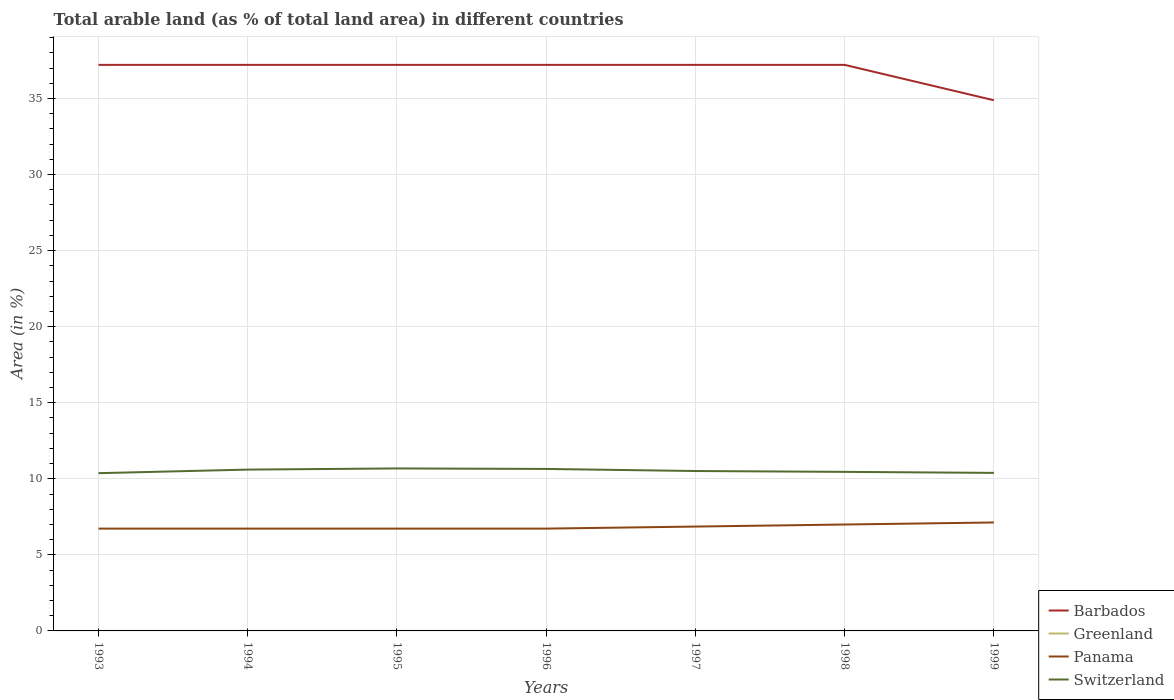Does the line corresponding to Barbados intersect with the line corresponding to Switzerland?
Make the answer very short. No. Is the number of lines equal to the number of legend labels?
Provide a succinct answer. Yes. Across all years, what is the maximum percentage of arable land in Barbados?
Give a very brief answer. 34.88. In which year was the percentage of arable land in Panama maximum?
Provide a short and direct response. 1993. What is the total percentage of arable land in Greenland in the graph?
Your answer should be compact. -0. What is the difference between the highest and the second highest percentage of arable land in Switzerland?
Ensure brevity in your answer.  0.31. What is the difference between the highest and the lowest percentage of arable land in Switzerland?
Give a very brief answer. 3. How many years are there in the graph?
Make the answer very short. 7. What is the difference between two consecutive major ticks on the Y-axis?
Offer a very short reply. 5. Does the graph contain grids?
Ensure brevity in your answer.  Yes. How are the legend labels stacked?
Offer a terse response. Vertical. What is the title of the graph?
Your answer should be very brief. Total arable land (as % of total land area) in different countries. Does "Portugal" appear as one of the legend labels in the graph?
Provide a short and direct response. No. What is the label or title of the X-axis?
Keep it short and to the point. Years. What is the label or title of the Y-axis?
Your answer should be compact. Area (in %). What is the Area (in %) of Barbados in 1993?
Provide a succinct answer. 37.21. What is the Area (in %) in Greenland in 1993?
Offer a very short reply. 0. What is the Area (in %) in Panama in 1993?
Provide a short and direct response. 6.73. What is the Area (in %) in Switzerland in 1993?
Give a very brief answer. 10.37. What is the Area (in %) in Barbados in 1994?
Make the answer very short. 37.21. What is the Area (in %) in Greenland in 1994?
Make the answer very short. 0. What is the Area (in %) of Panama in 1994?
Provide a succinct answer. 6.73. What is the Area (in %) of Switzerland in 1994?
Give a very brief answer. 10.6. What is the Area (in %) of Barbados in 1995?
Give a very brief answer. 37.21. What is the Area (in %) of Greenland in 1995?
Ensure brevity in your answer.  0. What is the Area (in %) in Panama in 1995?
Provide a short and direct response. 6.73. What is the Area (in %) of Switzerland in 1995?
Make the answer very short. 10.68. What is the Area (in %) in Barbados in 1996?
Your response must be concise. 37.21. What is the Area (in %) of Greenland in 1996?
Your answer should be compact. 0. What is the Area (in %) of Panama in 1996?
Offer a terse response. 6.73. What is the Area (in %) of Switzerland in 1996?
Provide a succinct answer. 10.65. What is the Area (in %) of Barbados in 1997?
Give a very brief answer. 37.21. What is the Area (in %) of Greenland in 1997?
Your answer should be compact. 0. What is the Area (in %) of Panama in 1997?
Make the answer very short. 6.86. What is the Area (in %) in Switzerland in 1997?
Give a very brief answer. 10.51. What is the Area (in %) in Barbados in 1998?
Provide a short and direct response. 37.21. What is the Area (in %) in Greenland in 1998?
Ensure brevity in your answer.  0. What is the Area (in %) in Panama in 1998?
Ensure brevity in your answer.  6.99. What is the Area (in %) in Switzerland in 1998?
Provide a short and direct response. 10.46. What is the Area (in %) of Barbados in 1999?
Keep it short and to the point. 34.88. What is the Area (in %) of Greenland in 1999?
Your answer should be compact. 0. What is the Area (in %) in Panama in 1999?
Offer a terse response. 7.13. What is the Area (in %) in Switzerland in 1999?
Ensure brevity in your answer.  10.39. Across all years, what is the maximum Area (in %) in Barbados?
Offer a very short reply. 37.21. Across all years, what is the maximum Area (in %) of Greenland?
Ensure brevity in your answer.  0. Across all years, what is the maximum Area (in %) in Panama?
Ensure brevity in your answer.  7.13. Across all years, what is the maximum Area (in %) of Switzerland?
Your answer should be very brief. 10.68. Across all years, what is the minimum Area (in %) in Barbados?
Your answer should be compact. 34.88. Across all years, what is the minimum Area (in %) in Greenland?
Offer a very short reply. 0. Across all years, what is the minimum Area (in %) of Panama?
Your response must be concise. 6.73. Across all years, what is the minimum Area (in %) in Switzerland?
Make the answer very short. 10.37. What is the total Area (in %) in Barbados in the graph?
Your answer should be very brief. 258.14. What is the total Area (in %) in Greenland in the graph?
Offer a very short reply. 0.01. What is the total Area (in %) of Panama in the graph?
Provide a short and direct response. 47.89. What is the total Area (in %) of Switzerland in the graph?
Your response must be concise. 73.66. What is the difference between the Area (in %) in Barbados in 1993 and that in 1994?
Offer a very short reply. 0. What is the difference between the Area (in %) in Greenland in 1993 and that in 1994?
Keep it short and to the point. 0. What is the difference between the Area (in %) in Panama in 1993 and that in 1994?
Give a very brief answer. 0. What is the difference between the Area (in %) of Switzerland in 1993 and that in 1994?
Your response must be concise. -0.24. What is the difference between the Area (in %) of Panama in 1993 and that in 1995?
Your answer should be very brief. 0. What is the difference between the Area (in %) of Switzerland in 1993 and that in 1995?
Offer a very short reply. -0.31. What is the difference between the Area (in %) of Barbados in 1993 and that in 1996?
Offer a very short reply. 0. What is the difference between the Area (in %) of Greenland in 1993 and that in 1996?
Offer a very short reply. -0. What is the difference between the Area (in %) in Switzerland in 1993 and that in 1996?
Provide a short and direct response. -0.28. What is the difference between the Area (in %) of Panama in 1993 and that in 1997?
Provide a short and direct response. -0.13. What is the difference between the Area (in %) of Switzerland in 1993 and that in 1997?
Ensure brevity in your answer.  -0.14. What is the difference between the Area (in %) of Panama in 1993 and that in 1998?
Ensure brevity in your answer.  -0.27. What is the difference between the Area (in %) of Switzerland in 1993 and that in 1998?
Provide a short and direct response. -0.09. What is the difference between the Area (in %) of Barbados in 1993 and that in 1999?
Your response must be concise. 2.33. What is the difference between the Area (in %) of Greenland in 1993 and that in 1999?
Provide a succinct answer. 0. What is the difference between the Area (in %) of Panama in 1993 and that in 1999?
Your answer should be compact. -0.4. What is the difference between the Area (in %) in Switzerland in 1993 and that in 1999?
Provide a succinct answer. -0.02. What is the difference between the Area (in %) of Panama in 1994 and that in 1995?
Offer a terse response. 0. What is the difference between the Area (in %) of Switzerland in 1994 and that in 1995?
Make the answer very short. -0.08. What is the difference between the Area (in %) of Barbados in 1994 and that in 1996?
Ensure brevity in your answer.  0. What is the difference between the Area (in %) of Greenland in 1994 and that in 1996?
Your response must be concise. -0. What is the difference between the Area (in %) in Switzerland in 1994 and that in 1996?
Offer a very short reply. -0.04. What is the difference between the Area (in %) of Panama in 1994 and that in 1997?
Your answer should be compact. -0.13. What is the difference between the Area (in %) in Switzerland in 1994 and that in 1997?
Make the answer very short. 0.09. What is the difference between the Area (in %) of Panama in 1994 and that in 1998?
Your response must be concise. -0.27. What is the difference between the Area (in %) in Switzerland in 1994 and that in 1998?
Ensure brevity in your answer.  0.15. What is the difference between the Area (in %) of Barbados in 1994 and that in 1999?
Offer a terse response. 2.33. What is the difference between the Area (in %) of Greenland in 1994 and that in 1999?
Your answer should be compact. 0. What is the difference between the Area (in %) in Panama in 1994 and that in 1999?
Keep it short and to the point. -0.4. What is the difference between the Area (in %) of Switzerland in 1994 and that in 1999?
Your answer should be compact. 0.22. What is the difference between the Area (in %) of Greenland in 1995 and that in 1996?
Provide a short and direct response. -0. What is the difference between the Area (in %) in Panama in 1995 and that in 1996?
Offer a very short reply. 0. What is the difference between the Area (in %) of Switzerland in 1995 and that in 1996?
Provide a short and direct response. 0.03. What is the difference between the Area (in %) of Greenland in 1995 and that in 1997?
Give a very brief answer. 0. What is the difference between the Area (in %) of Panama in 1995 and that in 1997?
Give a very brief answer. -0.13. What is the difference between the Area (in %) in Switzerland in 1995 and that in 1997?
Provide a succinct answer. 0.17. What is the difference between the Area (in %) of Barbados in 1995 and that in 1998?
Offer a very short reply. 0. What is the difference between the Area (in %) in Panama in 1995 and that in 1998?
Your answer should be compact. -0.27. What is the difference between the Area (in %) of Switzerland in 1995 and that in 1998?
Your response must be concise. 0.22. What is the difference between the Area (in %) of Barbados in 1995 and that in 1999?
Offer a very short reply. 2.33. What is the difference between the Area (in %) of Greenland in 1995 and that in 1999?
Give a very brief answer. 0. What is the difference between the Area (in %) in Panama in 1995 and that in 1999?
Your answer should be very brief. -0.4. What is the difference between the Area (in %) in Switzerland in 1995 and that in 1999?
Provide a succinct answer. 0.29. What is the difference between the Area (in %) of Panama in 1996 and that in 1997?
Make the answer very short. -0.13. What is the difference between the Area (in %) in Switzerland in 1996 and that in 1997?
Your answer should be very brief. 0.14. What is the difference between the Area (in %) of Barbados in 1996 and that in 1998?
Your answer should be very brief. 0. What is the difference between the Area (in %) in Greenland in 1996 and that in 1998?
Ensure brevity in your answer.  0. What is the difference between the Area (in %) of Panama in 1996 and that in 1998?
Your response must be concise. -0.27. What is the difference between the Area (in %) in Switzerland in 1996 and that in 1998?
Your response must be concise. 0.19. What is the difference between the Area (in %) in Barbados in 1996 and that in 1999?
Offer a very short reply. 2.33. What is the difference between the Area (in %) in Panama in 1996 and that in 1999?
Your answer should be compact. -0.4. What is the difference between the Area (in %) of Switzerland in 1996 and that in 1999?
Ensure brevity in your answer.  0.26. What is the difference between the Area (in %) of Barbados in 1997 and that in 1998?
Keep it short and to the point. 0. What is the difference between the Area (in %) in Panama in 1997 and that in 1998?
Ensure brevity in your answer.  -0.13. What is the difference between the Area (in %) in Switzerland in 1997 and that in 1998?
Offer a very short reply. 0.06. What is the difference between the Area (in %) in Barbados in 1997 and that in 1999?
Keep it short and to the point. 2.33. What is the difference between the Area (in %) in Greenland in 1997 and that in 1999?
Offer a very short reply. 0. What is the difference between the Area (in %) in Panama in 1997 and that in 1999?
Make the answer very short. -0.27. What is the difference between the Area (in %) in Switzerland in 1997 and that in 1999?
Give a very brief answer. 0.12. What is the difference between the Area (in %) in Barbados in 1998 and that in 1999?
Ensure brevity in your answer.  2.33. What is the difference between the Area (in %) in Panama in 1998 and that in 1999?
Your answer should be compact. -0.13. What is the difference between the Area (in %) in Switzerland in 1998 and that in 1999?
Provide a short and direct response. 0.07. What is the difference between the Area (in %) in Barbados in 1993 and the Area (in %) in Greenland in 1994?
Provide a short and direct response. 37.21. What is the difference between the Area (in %) in Barbados in 1993 and the Area (in %) in Panama in 1994?
Ensure brevity in your answer.  30.48. What is the difference between the Area (in %) of Barbados in 1993 and the Area (in %) of Switzerland in 1994?
Ensure brevity in your answer.  26.6. What is the difference between the Area (in %) in Greenland in 1993 and the Area (in %) in Panama in 1994?
Offer a very short reply. -6.72. What is the difference between the Area (in %) in Greenland in 1993 and the Area (in %) in Switzerland in 1994?
Offer a very short reply. -10.6. What is the difference between the Area (in %) in Panama in 1993 and the Area (in %) in Switzerland in 1994?
Your answer should be compact. -3.88. What is the difference between the Area (in %) of Barbados in 1993 and the Area (in %) of Greenland in 1995?
Your answer should be compact. 37.21. What is the difference between the Area (in %) in Barbados in 1993 and the Area (in %) in Panama in 1995?
Your answer should be very brief. 30.48. What is the difference between the Area (in %) in Barbados in 1993 and the Area (in %) in Switzerland in 1995?
Give a very brief answer. 26.53. What is the difference between the Area (in %) of Greenland in 1993 and the Area (in %) of Panama in 1995?
Provide a succinct answer. -6.72. What is the difference between the Area (in %) of Greenland in 1993 and the Area (in %) of Switzerland in 1995?
Provide a succinct answer. -10.68. What is the difference between the Area (in %) in Panama in 1993 and the Area (in %) in Switzerland in 1995?
Your response must be concise. -3.95. What is the difference between the Area (in %) in Barbados in 1993 and the Area (in %) in Greenland in 1996?
Ensure brevity in your answer.  37.21. What is the difference between the Area (in %) of Barbados in 1993 and the Area (in %) of Panama in 1996?
Make the answer very short. 30.48. What is the difference between the Area (in %) of Barbados in 1993 and the Area (in %) of Switzerland in 1996?
Keep it short and to the point. 26.56. What is the difference between the Area (in %) of Greenland in 1993 and the Area (in %) of Panama in 1996?
Provide a succinct answer. -6.72. What is the difference between the Area (in %) in Greenland in 1993 and the Area (in %) in Switzerland in 1996?
Offer a very short reply. -10.65. What is the difference between the Area (in %) of Panama in 1993 and the Area (in %) of Switzerland in 1996?
Offer a terse response. -3.92. What is the difference between the Area (in %) in Barbados in 1993 and the Area (in %) in Greenland in 1997?
Provide a succinct answer. 37.21. What is the difference between the Area (in %) in Barbados in 1993 and the Area (in %) in Panama in 1997?
Ensure brevity in your answer.  30.35. What is the difference between the Area (in %) in Barbados in 1993 and the Area (in %) in Switzerland in 1997?
Your response must be concise. 26.7. What is the difference between the Area (in %) of Greenland in 1993 and the Area (in %) of Panama in 1997?
Provide a short and direct response. -6.86. What is the difference between the Area (in %) of Greenland in 1993 and the Area (in %) of Switzerland in 1997?
Give a very brief answer. -10.51. What is the difference between the Area (in %) in Panama in 1993 and the Area (in %) in Switzerland in 1997?
Ensure brevity in your answer.  -3.79. What is the difference between the Area (in %) in Barbados in 1993 and the Area (in %) in Greenland in 1998?
Offer a terse response. 37.21. What is the difference between the Area (in %) in Barbados in 1993 and the Area (in %) in Panama in 1998?
Ensure brevity in your answer.  30.21. What is the difference between the Area (in %) of Barbados in 1993 and the Area (in %) of Switzerland in 1998?
Your response must be concise. 26.75. What is the difference between the Area (in %) in Greenland in 1993 and the Area (in %) in Panama in 1998?
Offer a very short reply. -6.99. What is the difference between the Area (in %) in Greenland in 1993 and the Area (in %) in Switzerland in 1998?
Provide a succinct answer. -10.45. What is the difference between the Area (in %) of Panama in 1993 and the Area (in %) of Switzerland in 1998?
Your response must be concise. -3.73. What is the difference between the Area (in %) of Barbados in 1993 and the Area (in %) of Greenland in 1999?
Make the answer very short. 37.21. What is the difference between the Area (in %) of Barbados in 1993 and the Area (in %) of Panama in 1999?
Offer a terse response. 30.08. What is the difference between the Area (in %) in Barbados in 1993 and the Area (in %) in Switzerland in 1999?
Your response must be concise. 26.82. What is the difference between the Area (in %) of Greenland in 1993 and the Area (in %) of Panama in 1999?
Offer a very short reply. -7.13. What is the difference between the Area (in %) of Greenland in 1993 and the Area (in %) of Switzerland in 1999?
Make the answer very short. -10.39. What is the difference between the Area (in %) of Panama in 1993 and the Area (in %) of Switzerland in 1999?
Your answer should be very brief. -3.66. What is the difference between the Area (in %) in Barbados in 1994 and the Area (in %) in Greenland in 1995?
Your answer should be compact. 37.21. What is the difference between the Area (in %) in Barbados in 1994 and the Area (in %) in Panama in 1995?
Ensure brevity in your answer.  30.48. What is the difference between the Area (in %) in Barbados in 1994 and the Area (in %) in Switzerland in 1995?
Provide a succinct answer. 26.53. What is the difference between the Area (in %) in Greenland in 1994 and the Area (in %) in Panama in 1995?
Your response must be concise. -6.72. What is the difference between the Area (in %) of Greenland in 1994 and the Area (in %) of Switzerland in 1995?
Your response must be concise. -10.68. What is the difference between the Area (in %) of Panama in 1994 and the Area (in %) of Switzerland in 1995?
Make the answer very short. -3.95. What is the difference between the Area (in %) in Barbados in 1994 and the Area (in %) in Greenland in 1996?
Offer a very short reply. 37.21. What is the difference between the Area (in %) of Barbados in 1994 and the Area (in %) of Panama in 1996?
Your response must be concise. 30.48. What is the difference between the Area (in %) of Barbados in 1994 and the Area (in %) of Switzerland in 1996?
Ensure brevity in your answer.  26.56. What is the difference between the Area (in %) in Greenland in 1994 and the Area (in %) in Panama in 1996?
Give a very brief answer. -6.72. What is the difference between the Area (in %) in Greenland in 1994 and the Area (in %) in Switzerland in 1996?
Ensure brevity in your answer.  -10.65. What is the difference between the Area (in %) in Panama in 1994 and the Area (in %) in Switzerland in 1996?
Ensure brevity in your answer.  -3.92. What is the difference between the Area (in %) of Barbados in 1994 and the Area (in %) of Greenland in 1997?
Offer a very short reply. 37.21. What is the difference between the Area (in %) in Barbados in 1994 and the Area (in %) in Panama in 1997?
Ensure brevity in your answer.  30.35. What is the difference between the Area (in %) in Barbados in 1994 and the Area (in %) in Switzerland in 1997?
Give a very brief answer. 26.7. What is the difference between the Area (in %) of Greenland in 1994 and the Area (in %) of Panama in 1997?
Your response must be concise. -6.86. What is the difference between the Area (in %) of Greenland in 1994 and the Area (in %) of Switzerland in 1997?
Keep it short and to the point. -10.51. What is the difference between the Area (in %) in Panama in 1994 and the Area (in %) in Switzerland in 1997?
Give a very brief answer. -3.79. What is the difference between the Area (in %) in Barbados in 1994 and the Area (in %) in Greenland in 1998?
Provide a succinct answer. 37.21. What is the difference between the Area (in %) in Barbados in 1994 and the Area (in %) in Panama in 1998?
Offer a very short reply. 30.21. What is the difference between the Area (in %) in Barbados in 1994 and the Area (in %) in Switzerland in 1998?
Give a very brief answer. 26.75. What is the difference between the Area (in %) in Greenland in 1994 and the Area (in %) in Panama in 1998?
Offer a terse response. -6.99. What is the difference between the Area (in %) in Greenland in 1994 and the Area (in %) in Switzerland in 1998?
Provide a succinct answer. -10.45. What is the difference between the Area (in %) of Panama in 1994 and the Area (in %) of Switzerland in 1998?
Keep it short and to the point. -3.73. What is the difference between the Area (in %) in Barbados in 1994 and the Area (in %) in Greenland in 1999?
Your answer should be very brief. 37.21. What is the difference between the Area (in %) in Barbados in 1994 and the Area (in %) in Panama in 1999?
Give a very brief answer. 30.08. What is the difference between the Area (in %) of Barbados in 1994 and the Area (in %) of Switzerland in 1999?
Make the answer very short. 26.82. What is the difference between the Area (in %) of Greenland in 1994 and the Area (in %) of Panama in 1999?
Your answer should be compact. -7.13. What is the difference between the Area (in %) of Greenland in 1994 and the Area (in %) of Switzerland in 1999?
Make the answer very short. -10.39. What is the difference between the Area (in %) of Panama in 1994 and the Area (in %) of Switzerland in 1999?
Your answer should be compact. -3.66. What is the difference between the Area (in %) in Barbados in 1995 and the Area (in %) in Greenland in 1996?
Offer a very short reply. 37.21. What is the difference between the Area (in %) in Barbados in 1995 and the Area (in %) in Panama in 1996?
Give a very brief answer. 30.48. What is the difference between the Area (in %) in Barbados in 1995 and the Area (in %) in Switzerland in 1996?
Make the answer very short. 26.56. What is the difference between the Area (in %) of Greenland in 1995 and the Area (in %) of Panama in 1996?
Keep it short and to the point. -6.72. What is the difference between the Area (in %) of Greenland in 1995 and the Area (in %) of Switzerland in 1996?
Offer a very short reply. -10.65. What is the difference between the Area (in %) of Panama in 1995 and the Area (in %) of Switzerland in 1996?
Give a very brief answer. -3.92. What is the difference between the Area (in %) in Barbados in 1995 and the Area (in %) in Greenland in 1997?
Your answer should be very brief. 37.21. What is the difference between the Area (in %) of Barbados in 1995 and the Area (in %) of Panama in 1997?
Your answer should be very brief. 30.35. What is the difference between the Area (in %) in Barbados in 1995 and the Area (in %) in Switzerland in 1997?
Give a very brief answer. 26.7. What is the difference between the Area (in %) in Greenland in 1995 and the Area (in %) in Panama in 1997?
Provide a succinct answer. -6.86. What is the difference between the Area (in %) in Greenland in 1995 and the Area (in %) in Switzerland in 1997?
Your answer should be very brief. -10.51. What is the difference between the Area (in %) of Panama in 1995 and the Area (in %) of Switzerland in 1997?
Give a very brief answer. -3.79. What is the difference between the Area (in %) of Barbados in 1995 and the Area (in %) of Greenland in 1998?
Your response must be concise. 37.21. What is the difference between the Area (in %) in Barbados in 1995 and the Area (in %) in Panama in 1998?
Offer a very short reply. 30.21. What is the difference between the Area (in %) in Barbados in 1995 and the Area (in %) in Switzerland in 1998?
Offer a very short reply. 26.75. What is the difference between the Area (in %) of Greenland in 1995 and the Area (in %) of Panama in 1998?
Make the answer very short. -6.99. What is the difference between the Area (in %) of Greenland in 1995 and the Area (in %) of Switzerland in 1998?
Offer a very short reply. -10.45. What is the difference between the Area (in %) of Panama in 1995 and the Area (in %) of Switzerland in 1998?
Give a very brief answer. -3.73. What is the difference between the Area (in %) in Barbados in 1995 and the Area (in %) in Greenland in 1999?
Your answer should be compact. 37.21. What is the difference between the Area (in %) in Barbados in 1995 and the Area (in %) in Panama in 1999?
Offer a very short reply. 30.08. What is the difference between the Area (in %) in Barbados in 1995 and the Area (in %) in Switzerland in 1999?
Offer a terse response. 26.82. What is the difference between the Area (in %) of Greenland in 1995 and the Area (in %) of Panama in 1999?
Make the answer very short. -7.13. What is the difference between the Area (in %) of Greenland in 1995 and the Area (in %) of Switzerland in 1999?
Offer a very short reply. -10.39. What is the difference between the Area (in %) of Panama in 1995 and the Area (in %) of Switzerland in 1999?
Provide a short and direct response. -3.66. What is the difference between the Area (in %) of Barbados in 1996 and the Area (in %) of Greenland in 1997?
Offer a terse response. 37.21. What is the difference between the Area (in %) in Barbados in 1996 and the Area (in %) in Panama in 1997?
Offer a terse response. 30.35. What is the difference between the Area (in %) of Barbados in 1996 and the Area (in %) of Switzerland in 1997?
Make the answer very short. 26.7. What is the difference between the Area (in %) of Greenland in 1996 and the Area (in %) of Panama in 1997?
Your response must be concise. -6.86. What is the difference between the Area (in %) in Greenland in 1996 and the Area (in %) in Switzerland in 1997?
Provide a short and direct response. -10.51. What is the difference between the Area (in %) in Panama in 1996 and the Area (in %) in Switzerland in 1997?
Provide a short and direct response. -3.79. What is the difference between the Area (in %) of Barbados in 1996 and the Area (in %) of Greenland in 1998?
Provide a succinct answer. 37.21. What is the difference between the Area (in %) of Barbados in 1996 and the Area (in %) of Panama in 1998?
Your answer should be very brief. 30.21. What is the difference between the Area (in %) of Barbados in 1996 and the Area (in %) of Switzerland in 1998?
Keep it short and to the point. 26.75. What is the difference between the Area (in %) in Greenland in 1996 and the Area (in %) in Panama in 1998?
Offer a very short reply. -6.99. What is the difference between the Area (in %) in Greenland in 1996 and the Area (in %) in Switzerland in 1998?
Provide a short and direct response. -10.45. What is the difference between the Area (in %) in Panama in 1996 and the Area (in %) in Switzerland in 1998?
Keep it short and to the point. -3.73. What is the difference between the Area (in %) in Barbados in 1996 and the Area (in %) in Greenland in 1999?
Make the answer very short. 37.21. What is the difference between the Area (in %) in Barbados in 1996 and the Area (in %) in Panama in 1999?
Ensure brevity in your answer.  30.08. What is the difference between the Area (in %) of Barbados in 1996 and the Area (in %) of Switzerland in 1999?
Offer a terse response. 26.82. What is the difference between the Area (in %) of Greenland in 1996 and the Area (in %) of Panama in 1999?
Provide a short and direct response. -7.13. What is the difference between the Area (in %) in Greenland in 1996 and the Area (in %) in Switzerland in 1999?
Make the answer very short. -10.39. What is the difference between the Area (in %) in Panama in 1996 and the Area (in %) in Switzerland in 1999?
Ensure brevity in your answer.  -3.66. What is the difference between the Area (in %) of Barbados in 1997 and the Area (in %) of Greenland in 1998?
Keep it short and to the point. 37.21. What is the difference between the Area (in %) of Barbados in 1997 and the Area (in %) of Panama in 1998?
Give a very brief answer. 30.21. What is the difference between the Area (in %) of Barbados in 1997 and the Area (in %) of Switzerland in 1998?
Your answer should be compact. 26.75. What is the difference between the Area (in %) of Greenland in 1997 and the Area (in %) of Panama in 1998?
Give a very brief answer. -6.99. What is the difference between the Area (in %) in Greenland in 1997 and the Area (in %) in Switzerland in 1998?
Give a very brief answer. -10.45. What is the difference between the Area (in %) in Panama in 1997 and the Area (in %) in Switzerland in 1998?
Your answer should be very brief. -3.6. What is the difference between the Area (in %) of Barbados in 1997 and the Area (in %) of Greenland in 1999?
Give a very brief answer. 37.21. What is the difference between the Area (in %) of Barbados in 1997 and the Area (in %) of Panama in 1999?
Make the answer very short. 30.08. What is the difference between the Area (in %) of Barbados in 1997 and the Area (in %) of Switzerland in 1999?
Offer a very short reply. 26.82. What is the difference between the Area (in %) in Greenland in 1997 and the Area (in %) in Panama in 1999?
Offer a very short reply. -7.13. What is the difference between the Area (in %) of Greenland in 1997 and the Area (in %) of Switzerland in 1999?
Offer a terse response. -10.39. What is the difference between the Area (in %) of Panama in 1997 and the Area (in %) of Switzerland in 1999?
Keep it short and to the point. -3.53. What is the difference between the Area (in %) in Barbados in 1998 and the Area (in %) in Greenland in 1999?
Ensure brevity in your answer.  37.21. What is the difference between the Area (in %) of Barbados in 1998 and the Area (in %) of Panama in 1999?
Provide a succinct answer. 30.08. What is the difference between the Area (in %) in Barbados in 1998 and the Area (in %) in Switzerland in 1999?
Offer a terse response. 26.82. What is the difference between the Area (in %) of Greenland in 1998 and the Area (in %) of Panama in 1999?
Your answer should be compact. -7.13. What is the difference between the Area (in %) of Greenland in 1998 and the Area (in %) of Switzerland in 1999?
Make the answer very short. -10.39. What is the difference between the Area (in %) of Panama in 1998 and the Area (in %) of Switzerland in 1999?
Provide a succinct answer. -3.39. What is the average Area (in %) in Barbados per year?
Offer a very short reply. 36.88. What is the average Area (in %) of Greenland per year?
Make the answer very short. 0. What is the average Area (in %) of Panama per year?
Your answer should be very brief. 6.84. What is the average Area (in %) of Switzerland per year?
Give a very brief answer. 10.52. In the year 1993, what is the difference between the Area (in %) of Barbados and Area (in %) of Greenland?
Give a very brief answer. 37.21. In the year 1993, what is the difference between the Area (in %) of Barbados and Area (in %) of Panama?
Provide a short and direct response. 30.48. In the year 1993, what is the difference between the Area (in %) in Barbados and Area (in %) in Switzerland?
Your answer should be very brief. 26.84. In the year 1993, what is the difference between the Area (in %) of Greenland and Area (in %) of Panama?
Offer a very short reply. -6.72. In the year 1993, what is the difference between the Area (in %) of Greenland and Area (in %) of Switzerland?
Give a very brief answer. -10.37. In the year 1993, what is the difference between the Area (in %) in Panama and Area (in %) in Switzerland?
Your response must be concise. -3.64. In the year 1994, what is the difference between the Area (in %) of Barbados and Area (in %) of Greenland?
Ensure brevity in your answer.  37.21. In the year 1994, what is the difference between the Area (in %) of Barbados and Area (in %) of Panama?
Provide a short and direct response. 30.48. In the year 1994, what is the difference between the Area (in %) in Barbados and Area (in %) in Switzerland?
Keep it short and to the point. 26.6. In the year 1994, what is the difference between the Area (in %) in Greenland and Area (in %) in Panama?
Give a very brief answer. -6.72. In the year 1994, what is the difference between the Area (in %) in Greenland and Area (in %) in Switzerland?
Ensure brevity in your answer.  -10.6. In the year 1994, what is the difference between the Area (in %) in Panama and Area (in %) in Switzerland?
Offer a terse response. -3.88. In the year 1995, what is the difference between the Area (in %) in Barbados and Area (in %) in Greenland?
Give a very brief answer. 37.21. In the year 1995, what is the difference between the Area (in %) of Barbados and Area (in %) of Panama?
Give a very brief answer. 30.48. In the year 1995, what is the difference between the Area (in %) of Barbados and Area (in %) of Switzerland?
Give a very brief answer. 26.53. In the year 1995, what is the difference between the Area (in %) of Greenland and Area (in %) of Panama?
Make the answer very short. -6.72. In the year 1995, what is the difference between the Area (in %) in Greenland and Area (in %) in Switzerland?
Provide a succinct answer. -10.68. In the year 1995, what is the difference between the Area (in %) of Panama and Area (in %) of Switzerland?
Give a very brief answer. -3.95. In the year 1996, what is the difference between the Area (in %) in Barbados and Area (in %) in Greenland?
Ensure brevity in your answer.  37.21. In the year 1996, what is the difference between the Area (in %) in Barbados and Area (in %) in Panama?
Provide a short and direct response. 30.48. In the year 1996, what is the difference between the Area (in %) in Barbados and Area (in %) in Switzerland?
Make the answer very short. 26.56. In the year 1996, what is the difference between the Area (in %) of Greenland and Area (in %) of Panama?
Your answer should be compact. -6.72. In the year 1996, what is the difference between the Area (in %) in Greenland and Area (in %) in Switzerland?
Give a very brief answer. -10.65. In the year 1996, what is the difference between the Area (in %) in Panama and Area (in %) in Switzerland?
Your response must be concise. -3.92. In the year 1997, what is the difference between the Area (in %) of Barbados and Area (in %) of Greenland?
Provide a succinct answer. 37.21. In the year 1997, what is the difference between the Area (in %) in Barbados and Area (in %) in Panama?
Provide a short and direct response. 30.35. In the year 1997, what is the difference between the Area (in %) of Barbados and Area (in %) of Switzerland?
Your answer should be very brief. 26.7. In the year 1997, what is the difference between the Area (in %) in Greenland and Area (in %) in Panama?
Your answer should be very brief. -6.86. In the year 1997, what is the difference between the Area (in %) in Greenland and Area (in %) in Switzerland?
Keep it short and to the point. -10.51. In the year 1997, what is the difference between the Area (in %) of Panama and Area (in %) of Switzerland?
Your answer should be very brief. -3.65. In the year 1998, what is the difference between the Area (in %) of Barbados and Area (in %) of Greenland?
Your answer should be very brief. 37.21. In the year 1998, what is the difference between the Area (in %) of Barbados and Area (in %) of Panama?
Offer a terse response. 30.21. In the year 1998, what is the difference between the Area (in %) in Barbados and Area (in %) in Switzerland?
Keep it short and to the point. 26.75. In the year 1998, what is the difference between the Area (in %) of Greenland and Area (in %) of Panama?
Provide a short and direct response. -6.99. In the year 1998, what is the difference between the Area (in %) of Greenland and Area (in %) of Switzerland?
Keep it short and to the point. -10.45. In the year 1998, what is the difference between the Area (in %) in Panama and Area (in %) in Switzerland?
Your answer should be compact. -3.46. In the year 1999, what is the difference between the Area (in %) of Barbados and Area (in %) of Greenland?
Provide a succinct answer. 34.88. In the year 1999, what is the difference between the Area (in %) in Barbados and Area (in %) in Panama?
Ensure brevity in your answer.  27.75. In the year 1999, what is the difference between the Area (in %) in Barbados and Area (in %) in Switzerland?
Keep it short and to the point. 24.5. In the year 1999, what is the difference between the Area (in %) of Greenland and Area (in %) of Panama?
Make the answer very short. -7.13. In the year 1999, what is the difference between the Area (in %) of Greenland and Area (in %) of Switzerland?
Your response must be concise. -10.39. In the year 1999, what is the difference between the Area (in %) in Panama and Area (in %) in Switzerland?
Offer a terse response. -3.26. What is the ratio of the Area (in %) of Barbados in 1993 to that in 1994?
Provide a succinct answer. 1. What is the ratio of the Area (in %) in Switzerland in 1993 to that in 1994?
Give a very brief answer. 0.98. What is the ratio of the Area (in %) in Barbados in 1993 to that in 1995?
Offer a very short reply. 1. What is the ratio of the Area (in %) of Greenland in 1993 to that in 1995?
Ensure brevity in your answer.  1. What is the ratio of the Area (in %) of Panama in 1993 to that in 1995?
Your answer should be very brief. 1. What is the ratio of the Area (in %) of Switzerland in 1993 to that in 1995?
Ensure brevity in your answer.  0.97. What is the ratio of the Area (in %) of Greenland in 1993 to that in 1996?
Make the answer very short. 0.86. What is the ratio of the Area (in %) of Panama in 1993 to that in 1996?
Ensure brevity in your answer.  1. What is the ratio of the Area (in %) in Switzerland in 1993 to that in 1996?
Your response must be concise. 0.97. What is the ratio of the Area (in %) of Barbados in 1993 to that in 1997?
Offer a terse response. 1. What is the ratio of the Area (in %) of Greenland in 1993 to that in 1997?
Your answer should be compact. 1.03. What is the ratio of the Area (in %) in Panama in 1993 to that in 1997?
Offer a terse response. 0.98. What is the ratio of the Area (in %) in Switzerland in 1993 to that in 1997?
Offer a terse response. 0.99. What is the ratio of the Area (in %) of Greenland in 1993 to that in 1998?
Keep it short and to the point. 1.03. What is the ratio of the Area (in %) of Panama in 1993 to that in 1998?
Offer a terse response. 0.96. What is the ratio of the Area (in %) in Barbados in 1993 to that in 1999?
Make the answer very short. 1.07. What is the ratio of the Area (in %) of Greenland in 1993 to that in 1999?
Your answer should be compact. 1.03. What is the ratio of the Area (in %) of Panama in 1993 to that in 1999?
Keep it short and to the point. 0.94. What is the ratio of the Area (in %) in Barbados in 1994 to that in 1995?
Your response must be concise. 1. What is the ratio of the Area (in %) in Switzerland in 1994 to that in 1995?
Your answer should be very brief. 0.99. What is the ratio of the Area (in %) in Greenland in 1994 to that in 1996?
Offer a terse response. 0.86. What is the ratio of the Area (in %) in Panama in 1994 to that in 1996?
Make the answer very short. 1. What is the ratio of the Area (in %) in Switzerland in 1994 to that in 1996?
Your answer should be very brief. 1. What is the ratio of the Area (in %) of Greenland in 1994 to that in 1997?
Your response must be concise. 1.03. What is the ratio of the Area (in %) in Panama in 1994 to that in 1997?
Give a very brief answer. 0.98. What is the ratio of the Area (in %) in Switzerland in 1994 to that in 1997?
Your answer should be very brief. 1.01. What is the ratio of the Area (in %) of Barbados in 1994 to that in 1998?
Your response must be concise. 1. What is the ratio of the Area (in %) of Greenland in 1994 to that in 1998?
Offer a very short reply. 1.03. What is the ratio of the Area (in %) in Panama in 1994 to that in 1998?
Your answer should be very brief. 0.96. What is the ratio of the Area (in %) in Switzerland in 1994 to that in 1998?
Offer a very short reply. 1.01. What is the ratio of the Area (in %) of Barbados in 1994 to that in 1999?
Your answer should be compact. 1.07. What is the ratio of the Area (in %) in Greenland in 1994 to that in 1999?
Give a very brief answer. 1.03. What is the ratio of the Area (in %) in Panama in 1994 to that in 1999?
Your response must be concise. 0.94. What is the ratio of the Area (in %) in Switzerland in 1994 to that in 1999?
Provide a succinct answer. 1.02. What is the ratio of the Area (in %) of Panama in 1995 to that in 1996?
Provide a short and direct response. 1. What is the ratio of the Area (in %) in Greenland in 1995 to that in 1997?
Ensure brevity in your answer.  1.03. What is the ratio of the Area (in %) of Panama in 1995 to that in 1997?
Your answer should be compact. 0.98. What is the ratio of the Area (in %) of Switzerland in 1995 to that in 1997?
Your answer should be compact. 1.02. What is the ratio of the Area (in %) in Barbados in 1995 to that in 1998?
Provide a succinct answer. 1. What is the ratio of the Area (in %) in Greenland in 1995 to that in 1998?
Offer a terse response. 1.03. What is the ratio of the Area (in %) in Panama in 1995 to that in 1998?
Your response must be concise. 0.96. What is the ratio of the Area (in %) in Switzerland in 1995 to that in 1998?
Provide a succinct answer. 1.02. What is the ratio of the Area (in %) of Barbados in 1995 to that in 1999?
Keep it short and to the point. 1.07. What is the ratio of the Area (in %) in Greenland in 1995 to that in 1999?
Keep it short and to the point. 1.03. What is the ratio of the Area (in %) of Panama in 1995 to that in 1999?
Your answer should be very brief. 0.94. What is the ratio of the Area (in %) of Switzerland in 1995 to that in 1999?
Give a very brief answer. 1.03. What is the ratio of the Area (in %) in Greenland in 1996 to that in 1997?
Your response must be concise. 1.2. What is the ratio of the Area (in %) of Panama in 1996 to that in 1997?
Offer a very short reply. 0.98. What is the ratio of the Area (in %) in Barbados in 1996 to that in 1998?
Keep it short and to the point. 1. What is the ratio of the Area (in %) in Greenland in 1996 to that in 1998?
Provide a short and direct response. 1.2. What is the ratio of the Area (in %) in Panama in 1996 to that in 1998?
Provide a short and direct response. 0.96. What is the ratio of the Area (in %) of Switzerland in 1996 to that in 1998?
Give a very brief answer. 1.02. What is the ratio of the Area (in %) in Barbados in 1996 to that in 1999?
Offer a terse response. 1.07. What is the ratio of the Area (in %) in Greenland in 1996 to that in 1999?
Give a very brief answer. 1.2. What is the ratio of the Area (in %) of Panama in 1996 to that in 1999?
Ensure brevity in your answer.  0.94. What is the ratio of the Area (in %) of Greenland in 1997 to that in 1998?
Offer a very short reply. 1. What is the ratio of the Area (in %) of Panama in 1997 to that in 1998?
Offer a very short reply. 0.98. What is the ratio of the Area (in %) in Barbados in 1997 to that in 1999?
Provide a short and direct response. 1.07. What is the ratio of the Area (in %) in Greenland in 1997 to that in 1999?
Provide a succinct answer. 1. What is the ratio of the Area (in %) in Panama in 1997 to that in 1999?
Ensure brevity in your answer.  0.96. What is the ratio of the Area (in %) in Switzerland in 1997 to that in 1999?
Give a very brief answer. 1.01. What is the ratio of the Area (in %) of Barbados in 1998 to that in 1999?
Your answer should be very brief. 1.07. What is the ratio of the Area (in %) of Greenland in 1998 to that in 1999?
Provide a succinct answer. 1. What is the ratio of the Area (in %) in Panama in 1998 to that in 1999?
Make the answer very short. 0.98. What is the ratio of the Area (in %) in Switzerland in 1998 to that in 1999?
Give a very brief answer. 1.01. What is the difference between the highest and the second highest Area (in %) of Panama?
Give a very brief answer. 0.13. What is the difference between the highest and the second highest Area (in %) of Switzerland?
Offer a very short reply. 0.03. What is the difference between the highest and the lowest Area (in %) in Barbados?
Ensure brevity in your answer.  2.33. What is the difference between the highest and the lowest Area (in %) of Panama?
Provide a succinct answer. 0.4. What is the difference between the highest and the lowest Area (in %) of Switzerland?
Offer a terse response. 0.31. 